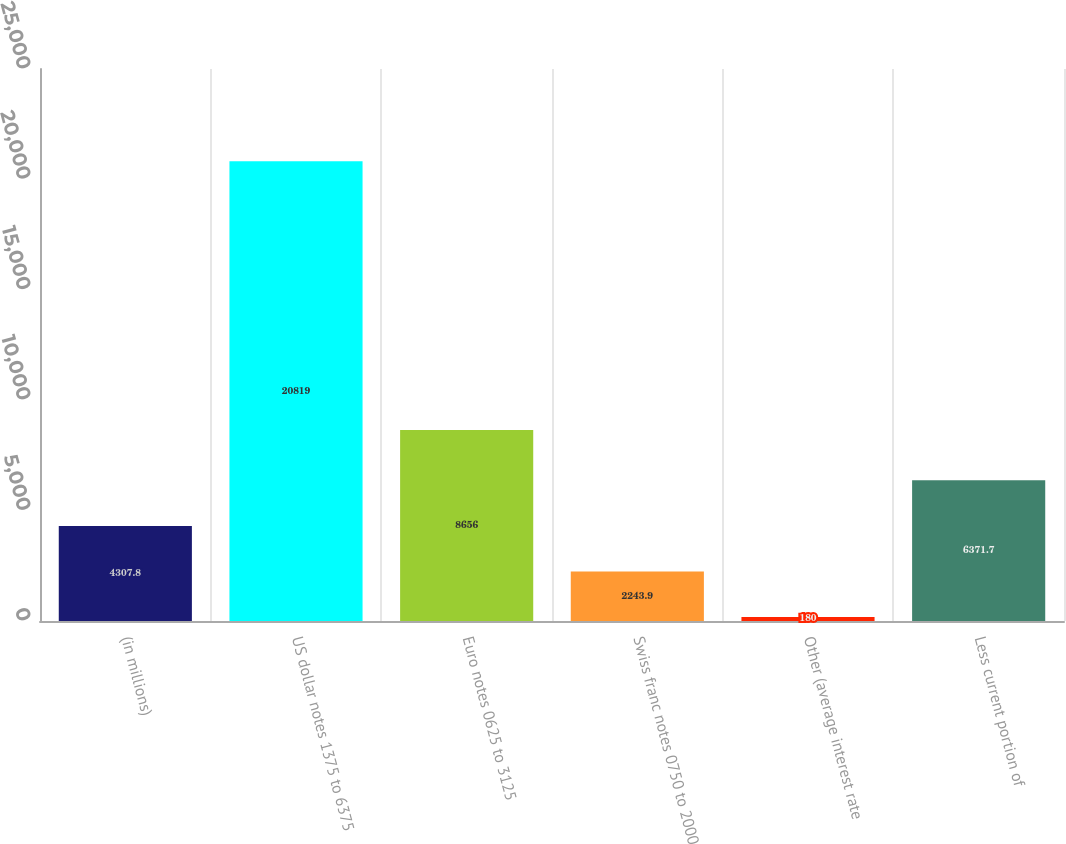Convert chart to OTSL. <chart><loc_0><loc_0><loc_500><loc_500><bar_chart><fcel>(in millions)<fcel>US dollar notes 1375 to 6375<fcel>Euro notes 0625 to 3125<fcel>Swiss franc notes 0750 to 2000<fcel>Other (average interest rate<fcel>Less current portion of<nl><fcel>4307.8<fcel>20819<fcel>8656<fcel>2243.9<fcel>180<fcel>6371.7<nl></chart> 